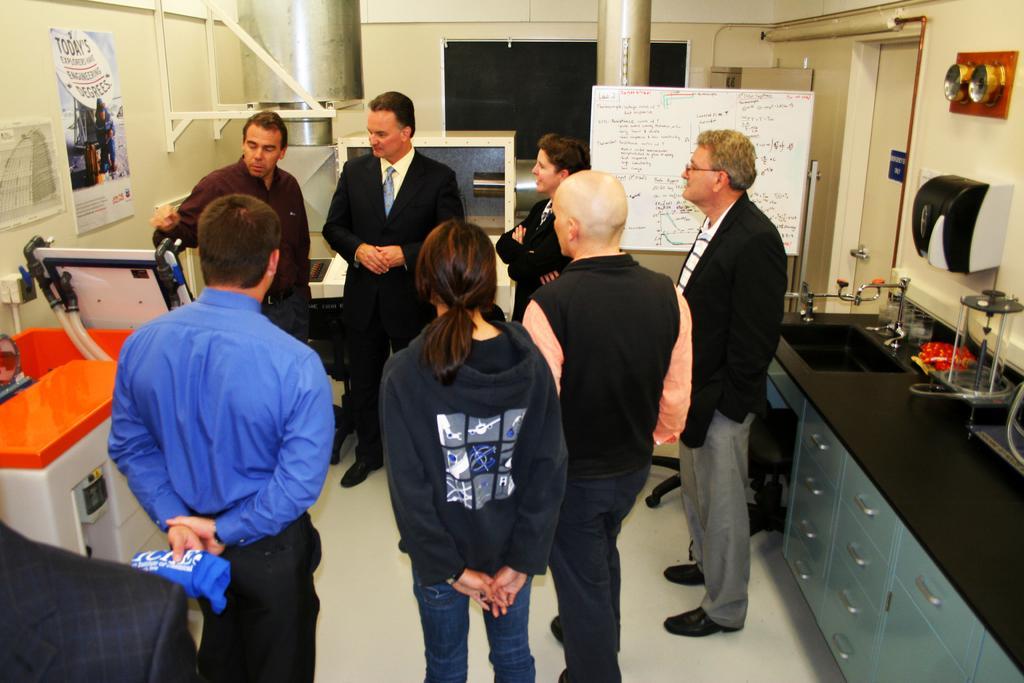Could you give a brief overview of what you see in this image? This is an inside view of a room. Here I can see few people standing on the floor. On the right side there is a table on which a tap and some other objects are placed. On the left side there are few machine tools which are placed on the floor and also there is a couch. At the top there are few posts attached to the wall. In the background, I can see two pillars and two boards. On the right side there is a door to the wall. 